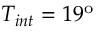<formula> <loc_0><loc_0><loc_500><loc_500>T _ { i n t } = 1 9 ^ { o }</formula> 